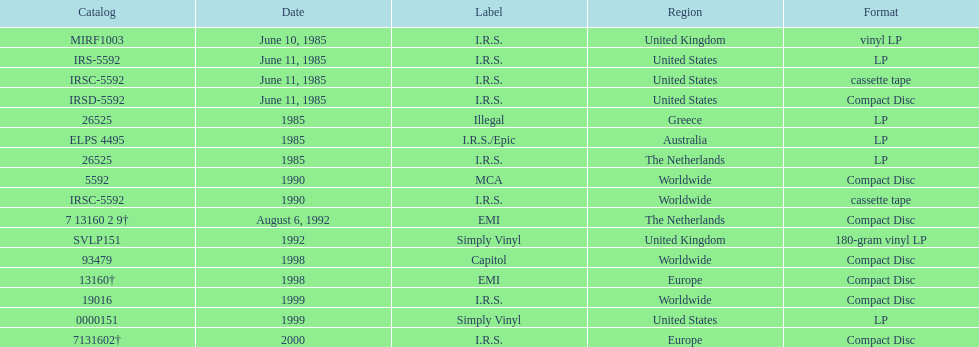What is the greatest consecutive amount of releases in lp format? 3. 